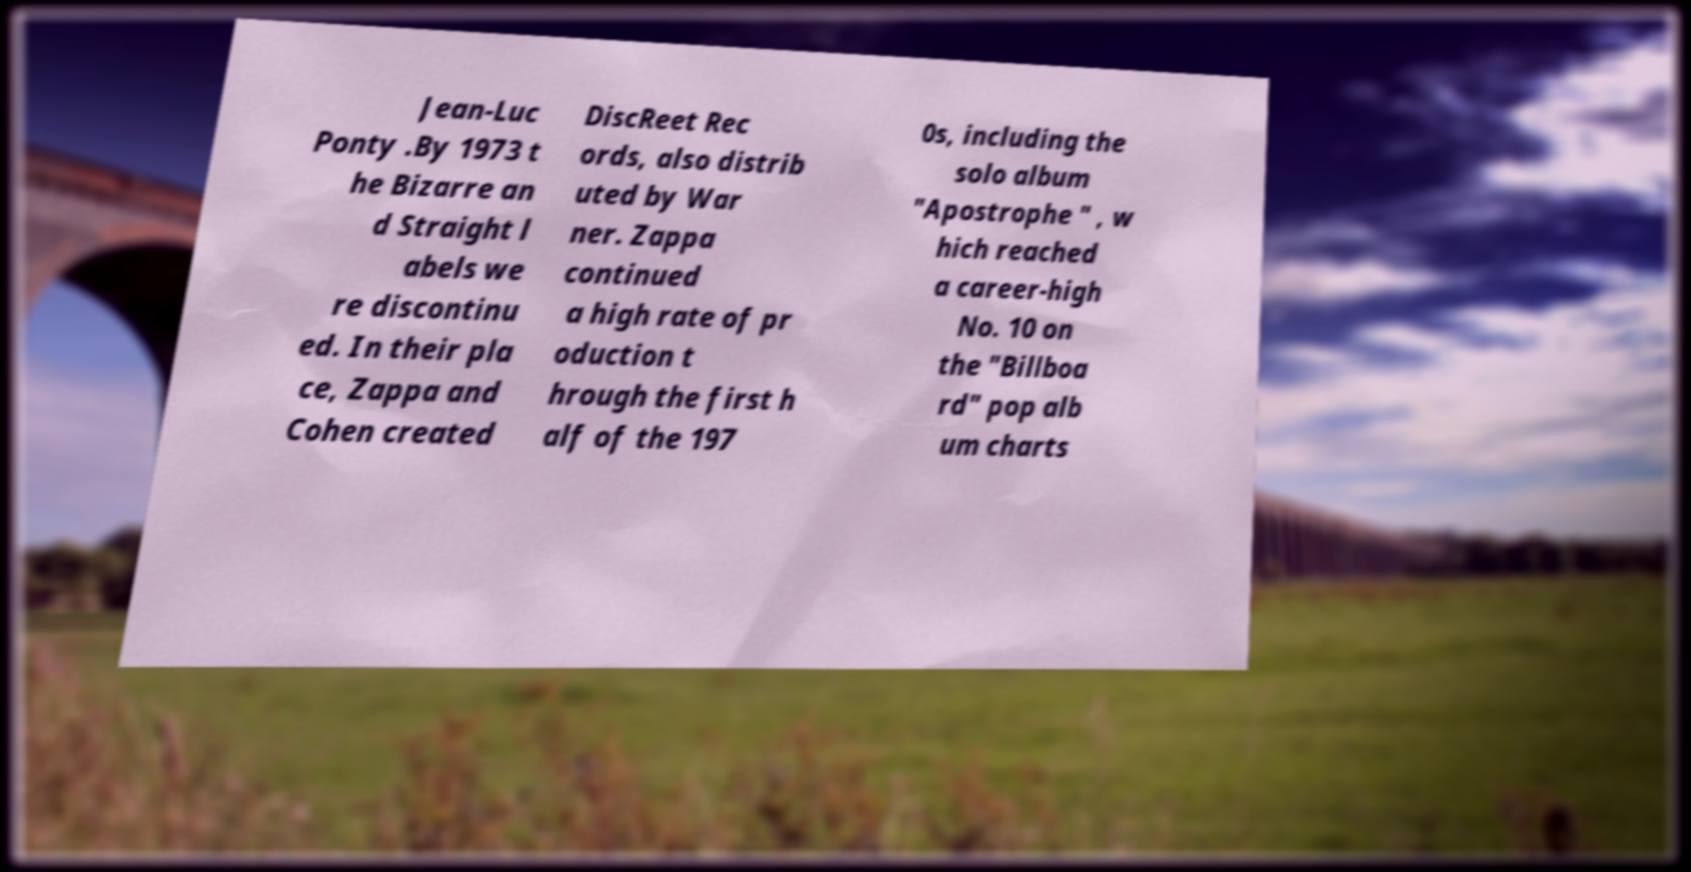Could you extract and type out the text from this image? Jean-Luc Ponty .By 1973 t he Bizarre an d Straight l abels we re discontinu ed. In their pla ce, Zappa and Cohen created DiscReet Rec ords, also distrib uted by War ner. Zappa continued a high rate of pr oduction t hrough the first h alf of the 197 0s, including the solo album "Apostrophe " , w hich reached a career-high No. 10 on the "Billboa rd" pop alb um charts 